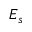<formula> <loc_0><loc_0><loc_500><loc_500>E _ { s }</formula> 